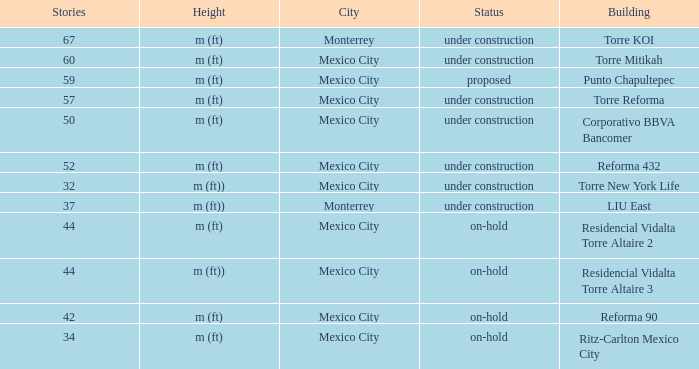What is the status of the torre reforma building that is over 44 stories in mexico city? Under construction. 